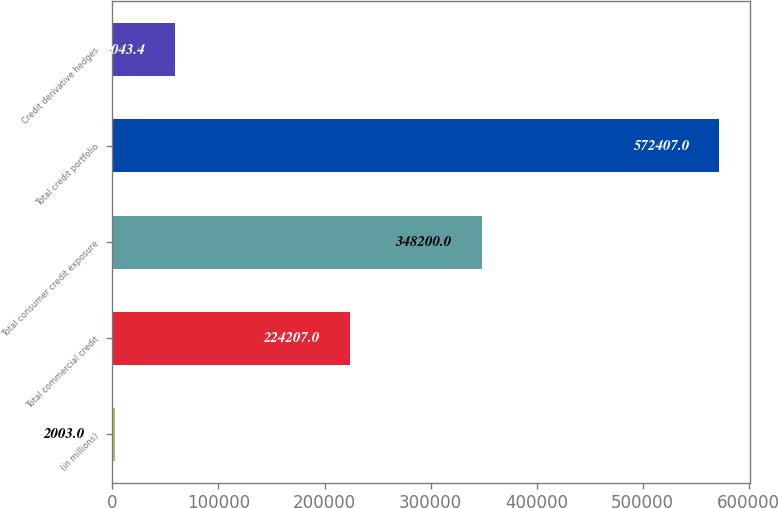<chart> <loc_0><loc_0><loc_500><loc_500><bar_chart><fcel>(in millions)<fcel>Total commercial credit<fcel>Total consumer credit exposure<fcel>Total credit portfolio<fcel>Credit derivative hedges<nl><fcel>2003<fcel>224207<fcel>348200<fcel>572407<fcel>59043.4<nl></chart> 